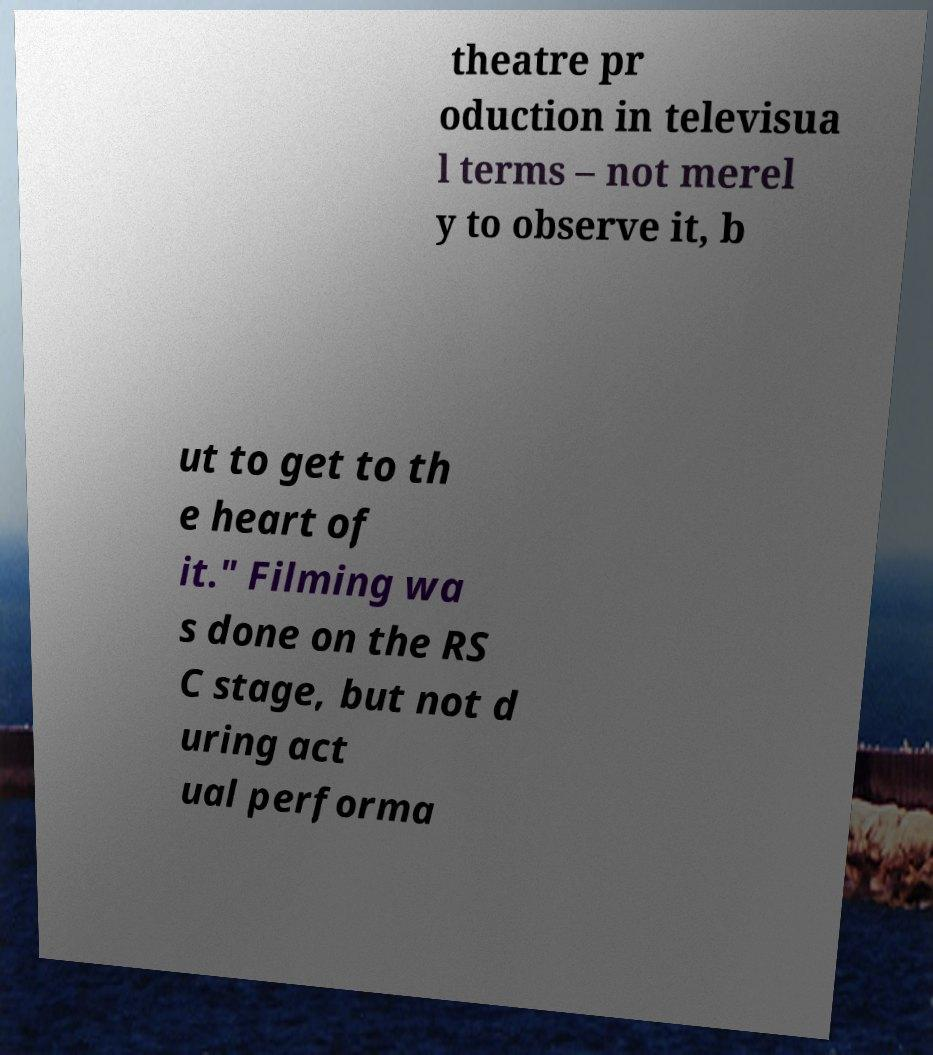Please read and relay the text visible in this image. What does it say? theatre pr oduction in televisua l terms – not merel y to observe it, b ut to get to th e heart of it." Filming wa s done on the RS C stage, but not d uring act ual performa 